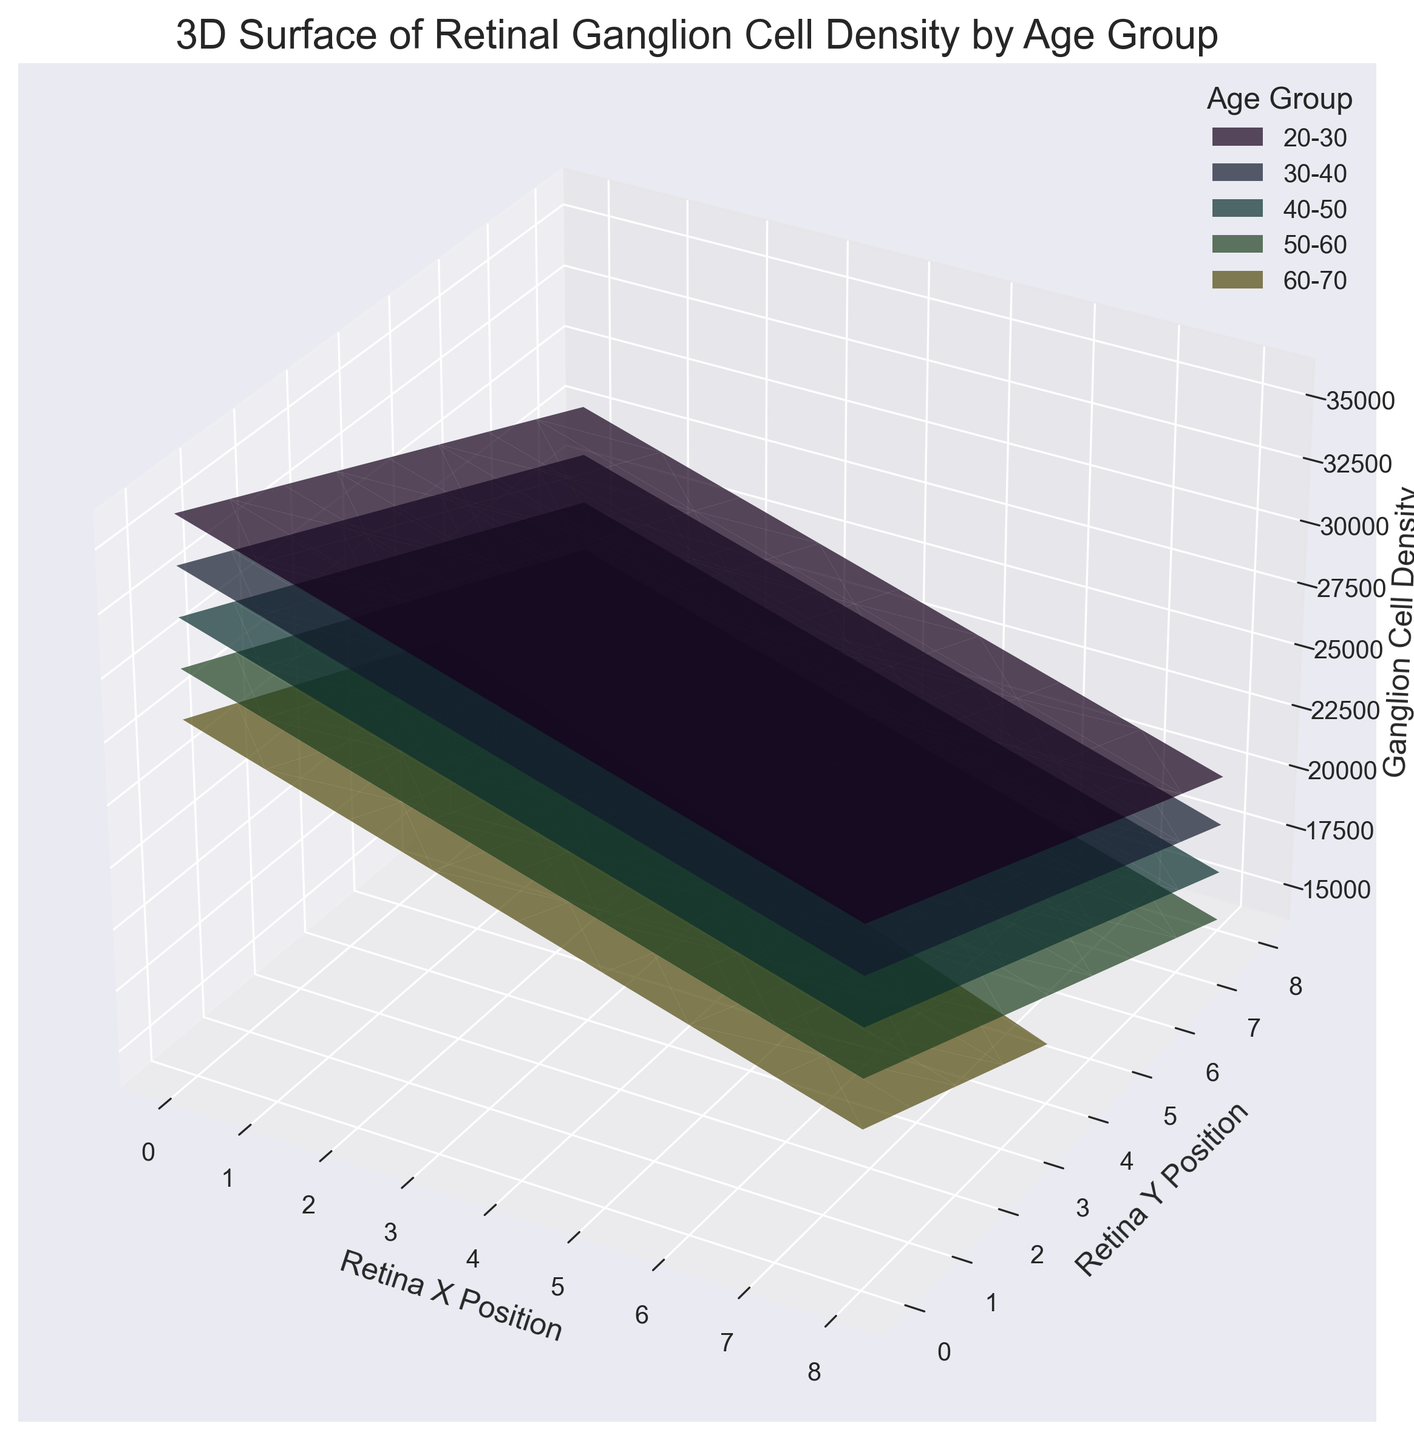What age group shows the highest average ganglion cell density across the retina? To find the highest average ganglion cell density, identify the peaks of each age group's surface plot. The 20-30 age group has the highest peaks, indicating the highest average density.
Answer: 20-30 Which age group has the most noticeable decline in ganglion cell density from the central to the peripheral retina? Compare the gradients of the surface plots for each age group. The 50-60 age group shows the steepest decline, indicating a noticeable decrease from the center to the periphery.
Answer: 50-60 How does the ganglion cell density at the [0,0] retina position change with age? Observe the Z-axis values at the [0,0] position across different age groups: it decreases from 36000 for 20-30 to 28000 for 60-70.
Answer: It decreases At which retina position does the 30-40 age group have the highest ganglion cell density? Examine the highest peak(s) within the 30-40 age group's surface plot. The position [0,0] has the highest density.
Answer: [0,0] Compare the retinal ganglion cell density at position [4,4] for the age groups 20-30 and 40-50. Which age group has a higher density? Look at the Z-axis values for position [4,4]. For 20-30, it is 28000, and for 40-50, it is 24000; thus, 20-30 is higher.
Answer: 20-30 Which age group shows a more uniform distribution of ganglion cell density across the retina? Compare the smoothness of the surface plots across all positions for each age group. The 60-70 age group's plot appears more uniform without steep variations.
Answer: 60-70 Is the ganglion cell density at position [8,8] greater for age group 50-60 or 60-70? Compare Z-axis values at [8,8]. For 50-60, it is 14000 and for 60-70, it is 16000; thus, 60-70 is greater.
Answer: 60-70 What is the general trend in ganglion cell density as age increases at the central retina (e.g., position [0,0])? Examine the density values at [0,0] for all age groups: it decreases consistently with increasing age.
Answer: Decreases What pattern is observed in ganglion cell density across the retina for the 20-30 age group? The surface plot for 20-30 shows a gradual decrease from the center to the periphery.
Answer: Gradual decrease Comparatively, how does the peripheral ganglion cell density in the 40-50 age group differ from the 20-30 age group? Observe peripheral points (e.g., around [8,8]). The 40-50 age group has noticeably lower density values compared to the 20-30 age group.
Answer: Lower 